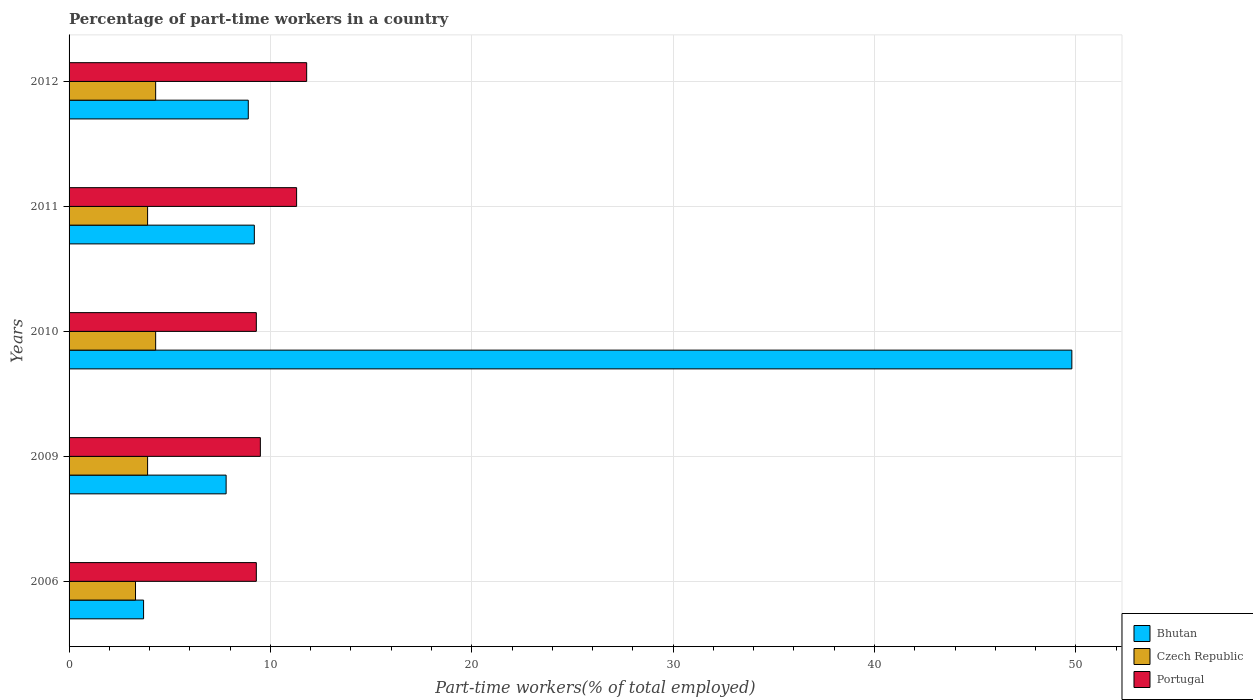Are the number of bars on each tick of the Y-axis equal?
Ensure brevity in your answer.  Yes. What is the label of the 4th group of bars from the top?
Ensure brevity in your answer.  2009. In how many cases, is the number of bars for a given year not equal to the number of legend labels?
Make the answer very short. 0. What is the percentage of part-time workers in Czech Republic in 2009?
Offer a terse response. 3.9. Across all years, what is the maximum percentage of part-time workers in Portugal?
Give a very brief answer. 11.8. Across all years, what is the minimum percentage of part-time workers in Bhutan?
Give a very brief answer. 3.7. In which year was the percentage of part-time workers in Portugal minimum?
Ensure brevity in your answer.  2006. What is the total percentage of part-time workers in Bhutan in the graph?
Provide a succinct answer. 79.4. What is the difference between the percentage of part-time workers in Czech Republic in 2010 and the percentage of part-time workers in Portugal in 2012?
Your response must be concise. -7.5. What is the average percentage of part-time workers in Portugal per year?
Make the answer very short. 10.24. In the year 2012, what is the difference between the percentage of part-time workers in Portugal and percentage of part-time workers in Czech Republic?
Your response must be concise. 7.5. In how many years, is the percentage of part-time workers in Czech Republic greater than 24 %?
Keep it short and to the point. 0. What is the ratio of the percentage of part-time workers in Bhutan in 2009 to that in 2010?
Your answer should be very brief. 0.16. Is the difference between the percentage of part-time workers in Portugal in 2006 and 2010 greater than the difference between the percentage of part-time workers in Czech Republic in 2006 and 2010?
Make the answer very short. Yes. What is the difference between the highest and the lowest percentage of part-time workers in Portugal?
Offer a very short reply. 2.5. In how many years, is the percentage of part-time workers in Portugal greater than the average percentage of part-time workers in Portugal taken over all years?
Provide a short and direct response. 2. Is the sum of the percentage of part-time workers in Czech Republic in 2006 and 2009 greater than the maximum percentage of part-time workers in Bhutan across all years?
Keep it short and to the point. No. What does the 2nd bar from the bottom in 2006 represents?
Your answer should be very brief. Czech Republic. Is it the case that in every year, the sum of the percentage of part-time workers in Bhutan and percentage of part-time workers in Portugal is greater than the percentage of part-time workers in Czech Republic?
Make the answer very short. Yes. How many years are there in the graph?
Offer a very short reply. 5. Where does the legend appear in the graph?
Make the answer very short. Bottom right. What is the title of the graph?
Your response must be concise. Percentage of part-time workers in a country. What is the label or title of the X-axis?
Provide a succinct answer. Part-time workers(% of total employed). What is the label or title of the Y-axis?
Offer a terse response. Years. What is the Part-time workers(% of total employed) of Bhutan in 2006?
Your answer should be very brief. 3.7. What is the Part-time workers(% of total employed) in Czech Republic in 2006?
Offer a terse response. 3.3. What is the Part-time workers(% of total employed) of Portugal in 2006?
Your answer should be compact. 9.3. What is the Part-time workers(% of total employed) in Bhutan in 2009?
Your answer should be compact. 7.8. What is the Part-time workers(% of total employed) in Czech Republic in 2009?
Make the answer very short. 3.9. What is the Part-time workers(% of total employed) in Portugal in 2009?
Ensure brevity in your answer.  9.5. What is the Part-time workers(% of total employed) of Bhutan in 2010?
Offer a very short reply. 49.8. What is the Part-time workers(% of total employed) in Czech Republic in 2010?
Provide a short and direct response. 4.3. What is the Part-time workers(% of total employed) in Portugal in 2010?
Offer a terse response. 9.3. What is the Part-time workers(% of total employed) in Bhutan in 2011?
Give a very brief answer. 9.2. What is the Part-time workers(% of total employed) in Czech Republic in 2011?
Your response must be concise. 3.9. What is the Part-time workers(% of total employed) of Portugal in 2011?
Your answer should be compact. 11.3. What is the Part-time workers(% of total employed) of Bhutan in 2012?
Provide a succinct answer. 8.9. What is the Part-time workers(% of total employed) in Czech Republic in 2012?
Provide a short and direct response. 4.3. What is the Part-time workers(% of total employed) in Portugal in 2012?
Your answer should be compact. 11.8. Across all years, what is the maximum Part-time workers(% of total employed) of Bhutan?
Make the answer very short. 49.8. Across all years, what is the maximum Part-time workers(% of total employed) of Czech Republic?
Offer a terse response. 4.3. Across all years, what is the maximum Part-time workers(% of total employed) of Portugal?
Your answer should be very brief. 11.8. Across all years, what is the minimum Part-time workers(% of total employed) in Bhutan?
Keep it short and to the point. 3.7. Across all years, what is the minimum Part-time workers(% of total employed) of Czech Republic?
Your answer should be very brief. 3.3. Across all years, what is the minimum Part-time workers(% of total employed) of Portugal?
Offer a very short reply. 9.3. What is the total Part-time workers(% of total employed) of Bhutan in the graph?
Offer a terse response. 79.4. What is the total Part-time workers(% of total employed) of Portugal in the graph?
Make the answer very short. 51.2. What is the difference between the Part-time workers(% of total employed) in Bhutan in 2006 and that in 2009?
Your answer should be compact. -4.1. What is the difference between the Part-time workers(% of total employed) of Portugal in 2006 and that in 2009?
Your response must be concise. -0.2. What is the difference between the Part-time workers(% of total employed) in Bhutan in 2006 and that in 2010?
Your answer should be compact. -46.1. What is the difference between the Part-time workers(% of total employed) of Bhutan in 2006 and that in 2011?
Keep it short and to the point. -5.5. What is the difference between the Part-time workers(% of total employed) of Czech Republic in 2006 and that in 2011?
Offer a terse response. -0.6. What is the difference between the Part-time workers(% of total employed) in Bhutan in 2006 and that in 2012?
Your answer should be very brief. -5.2. What is the difference between the Part-time workers(% of total employed) in Portugal in 2006 and that in 2012?
Keep it short and to the point. -2.5. What is the difference between the Part-time workers(% of total employed) of Bhutan in 2009 and that in 2010?
Ensure brevity in your answer.  -42. What is the difference between the Part-time workers(% of total employed) of Czech Republic in 2009 and that in 2010?
Your answer should be very brief. -0.4. What is the difference between the Part-time workers(% of total employed) in Czech Republic in 2009 and that in 2011?
Keep it short and to the point. 0. What is the difference between the Part-time workers(% of total employed) of Bhutan in 2009 and that in 2012?
Keep it short and to the point. -1.1. What is the difference between the Part-time workers(% of total employed) in Bhutan in 2010 and that in 2011?
Offer a terse response. 40.6. What is the difference between the Part-time workers(% of total employed) of Czech Republic in 2010 and that in 2011?
Ensure brevity in your answer.  0.4. What is the difference between the Part-time workers(% of total employed) in Bhutan in 2010 and that in 2012?
Ensure brevity in your answer.  40.9. What is the difference between the Part-time workers(% of total employed) of Bhutan in 2011 and that in 2012?
Your answer should be compact. 0.3. What is the difference between the Part-time workers(% of total employed) of Czech Republic in 2011 and that in 2012?
Your answer should be very brief. -0.4. What is the difference between the Part-time workers(% of total employed) of Bhutan in 2006 and the Part-time workers(% of total employed) of Czech Republic in 2009?
Ensure brevity in your answer.  -0.2. What is the difference between the Part-time workers(% of total employed) of Bhutan in 2006 and the Part-time workers(% of total employed) of Portugal in 2009?
Your answer should be very brief. -5.8. What is the difference between the Part-time workers(% of total employed) in Bhutan in 2006 and the Part-time workers(% of total employed) in Czech Republic in 2010?
Make the answer very short. -0.6. What is the difference between the Part-time workers(% of total employed) of Czech Republic in 2006 and the Part-time workers(% of total employed) of Portugal in 2010?
Offer a very short reply. -6. What is the difference between the Part-time workers(% of total employed) in Bhutan in 2006 and the Part-time workers(% of total employed) in Czech Republic in 2011?
Make the answer very short. -0.2. What is the difference between the Part-time workers(% of total employed) of Bhutan in 2006 and the Part-time workers(% of total employed) of Portugal in 2011?
Ensure brevity in your answer.  -7.6. What is the difference between the Part-time workers(% of total employed) in Bhutan in 2006 and the Part-time workers(% of total employed) in Czech Republic in 2012?
Your answer should be very brief. -0.6. What is the difference between the Part-time workers(% of total employed) in Bhutan in 2009 and the Part-time workers(% of total employed) in Czech Republic in 2010?
Offer a terse response. 3.5. What is the difference between the Part-time workers(% of total employed) in Czech Republic in 2009 and the Part-time workers(% of total employed) in Portugal in 2011?
Give a very brief answer. -7.4. What is the difference between the Part-time workers(% of total employed) in Bhutan in 2009 and the Part-time workers(% of total employed) in Czech Republic in 2012?
Make the answer very short. 3.5. What is the difference between the Part-time workers(% of total employed) of Bhutan in 2010 and the Part-time workers(% of total employed) of Czech Republic in 2011?
Ensure brevity in your answer.  45.9. What is the difference between the Part-time workers(% of total employed) in Bhutan in 2010 and the Part-time workers(% of total employed) in Portugal in 2011?
Give a very brief answer. 38.5. What is the difference between the Part-time workers(% of total employed) of Czech Republic in 2010 and the Part-time workers(% of total employed) of Portugal in 2011?
Keep it short and to the point. -7. What is the difference between the Part-time workers(% of total employed) of Bhutan in 2010 and the Part-time workers(% of total employed) of Czech Republic in 2012?
Provide a short and direct response. 45.5. What is the difference between the Part-time workers(% of total employed) in Bhutan in 2011 and the Part-time workers(% of total employed) in Czech Republic in 2012?
Provide a short and direct response. 4.9. What is the difference between the Part-time workers(% of total employed) of Czech Republic in 2011 and the Part-time workers(% of total employed) of Portugal in 2012?
Provide a succinct answer. -7.9. What is the average Part-time workers(% of total employed) of Bhutan per year?
Make the answer very short. 15.88. What is the average Part-time workers(% of total employed) of Czech Republic per year?
Provide a short and direct response. 3.94. What is the average Part-time workers(% of total employed) in Portugal per year?
Your answer should be compact. 10.24. In the year 2006, what is the difference between the Part-time workers(% of total employed) of Bhutan and Part-time workers(% of total employed) of Czech Republic?
Keep it short and to the point. 0.4. In the year 2006, what is the difference between the Part-time workers(% of total employed) of Czech Republic and Part-time workers(% of total employed) of Portugal?
Offer a terse response. -6. In the year 2009, what is the difference between the Part-time workers(% of total employed) in Bhutan and Part-time workers(% of total employed) in Portugal?
Your answer should be compact. -1.7. In the year 2009, what is the difference between the Part-time workers(% of total employed) of Czech Republic and Part-time workers(% of total employed) of Portugal?
Offer a very short reply. -5.6. In the year 2010, what is the difference between the Part-time workers(% of total employed) of Bhutan and Part-time workers(% of total employed) of Czech Republic?
Provide a succinct answer. 45.5. In the year 2010, what is the difference between the Part-time workers(% of total employed) of Bhutan and Part-time workers(% of total employed) of Portugal?
Keep it short and to the point. 40.5. In the year 2011, what is the difference between the Part-time workers(% of total employed) of Bhutan and Part-time workers(% of total employed) of Czech Republic?
Ensure brevity in your answer.  5.3. In the year 2011, what is the difference between the Part-time workers(% of total employed) in Czech Republic and Part-time workers(% of total employed) in Portugal?
Provide a short and direct response. -7.4. In the year 2012, what is the difference between the Part-time workers(% of total employed) of Bhutan and Part-time workers(% of total employed) of Czech Republic?
Your response must be concise. 4.6. In the year 2012, what is the difference between the Part-time workers(% of total employed) in Czech Republic and Part-time workers(% of total employed) in Portugal?
Your response must be concise. -7.5. What is the ratio of the Part-time workers(% of total employed) of Bhutan in 2006 to that in 2009?
Offer a very short reply. 0.47. What is the ratio of the Part-time workers(% of total employed) of Czech Republic in 2006 to that in 2009?
Your response must be concise. 0.85. What is the ratio of the Part-time workers(% of total employed) in Portugal in 2006 to that in 2009?
Provide a succinct answer. 0.98. What is the ratio of the Part-time workers(% of total employed) in Bhutan in 2006 to that in 2010?
Ensure brevity in your answer.  0.07. What is the ratio of the Part-time workers(% of total employed) in Czech Republic in 2006 to that in 2010?
Make the answer very short. 0.77. What is the ratio of the Part-time workers(% of total employed) of Bhutan in 2006 to that in 2011?
Keep it short and to the point. 0.4. What is the ratio of the Part-time workers(% of total employed) in Czech Republic in 2006 to that in 2011?
Provide a succinct answer. 0.85. What is the ratio of the Part-time workers(% of total employed) in Portugal in 2006 to that in 2011?
Ensure brevity in your answer.  0.82. What is the ratio of the Part-time workers(% of total employed) of Bhutan in 2006 to that in 2012?
Your answer should be very brief. 0.42. What is the ratio of the Part-time workers(% of total employed) of Czech Republic in 2006 to that in 2012?
Keep it short and to the point. 0.77. What is the ratio of the Part-time workers(% of total employed) in Portugal in 2006 to that in 2012?
Your answer should be very brief. 0.79. What is the ratio of the Part-time workers(% of total employed) of Bhutan in 2009 to that in 2010?
Your answer should be compact. 0.16. What is the ratio of the Part-time workers(% of total employed) in Czech Republic in 2009 to that in 2010?
Your answer should be compact. 0.91. What is the ratio of the Part-time workers(% of total employed) of Portugal in 2009 to that in 2010?
Give a very brief answer. 1.02. What is the ratio of the Part-time workers(% of total employed) in Bhutan in 2009 to that in 2011?
Your response must be concise. 0.85. What is the ratio of the Part-time workers(% of total employed) in Czech Republic in 2009 to that in 2011?
Make the answer very short. 1. What is the ratio of the Part-time workers(% of total employed) of Portugal in 2009 to that in 2011?
Your response must be concise. 0.84. What is the ratio of the Part-time workers(% of total employed) of Bhutan in 2009 to that in 2012?
Provide a succinct answer. 0.88. What is the ratio of the Part-time workers(% of total employed) in Czech Republic in 2009 to that in 2012?
Give a very brief answer. 0.91. What is the ratio of the Part-time workers(% of total employed) in Portugal in 2009 to that in 2012?
Give a very brief answer. 0.81. What is the ratio of the Part-time workers(% of total employed) of Bhutan in 2010 to that in 2011?
Offer a very short reply. 5.41. What is the ratio of the Part-time workers(% of total employed) in Czech Republic in 2010 to that in 2011?
Provide a succinct answer. 1.1. What is the ratio of the Part-time workers(% of total employed) of Portugal in 2010 to that in 2011?
Your answer should be compact. 0.82. What is the ratio of the Part-time workers(% of total employed) of Bhutan in 2010 to that in 2012?
Your answer should be compact. 5.6. What is the ratio of the Part-time workers(% of total employed) in Czech Republic in 2010 to that in 2012?
Give a very brief answer. 1. What is the ratio of the Part-time workers(% of total employed) of Portugal in 2010 to that in 2012?
Ensure brevity in your answer.  0.79. What is the ratio of the Part-time workers(% of total employed) in Bhutan in 2011 to that in 2012?
Make the answer very short. 1.03. What is the ratio of the Part-time workers(% of total employed) in Czech Republic in 2011 to that in 2012?
Keep it short and to the point. 0.91. What is the ratio of the Part-time workers(% of total employed) of Portugal in 2011 to that in 2012?
Provide a succinct answer. 0.96. What is the difference between the highest and the second highest Part-time workers(% of total employed) of Bhutan?
Provide a short and direct response. 40.6. What is the difference between the highest and the lowest Part-time workers(% of total employed) of Bhutan?
Your response must be concise. 46.1. 